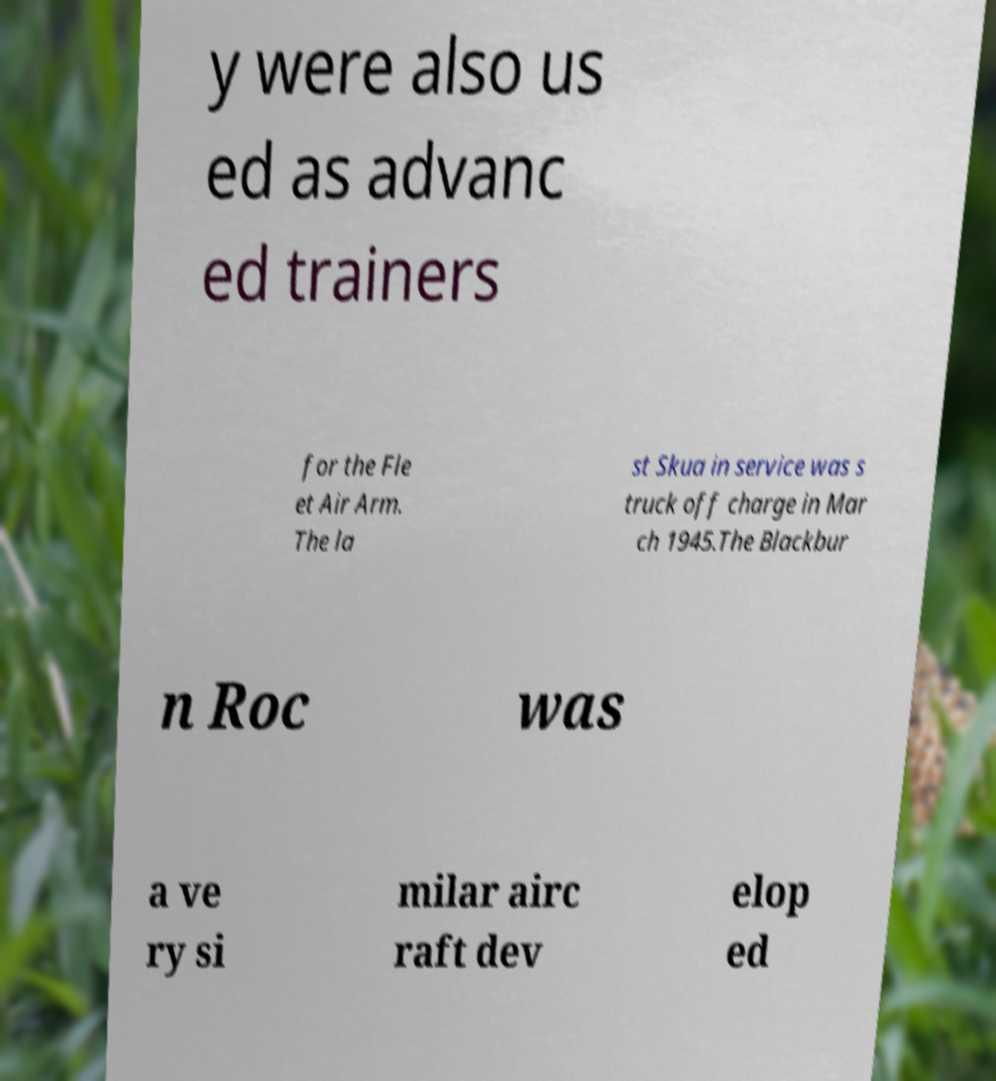Can you read and provide the text displayed in the image?This photo seems to have some interesting text. Can you extract and type it out for me? y were also us ed as advanc ed trainers for the Fle et Air Arm. The la st Skua in service was s truck off charge in Mar ch 1945.The Blackbur n Roc was a ve ry si milar airc raft dev elop ed 